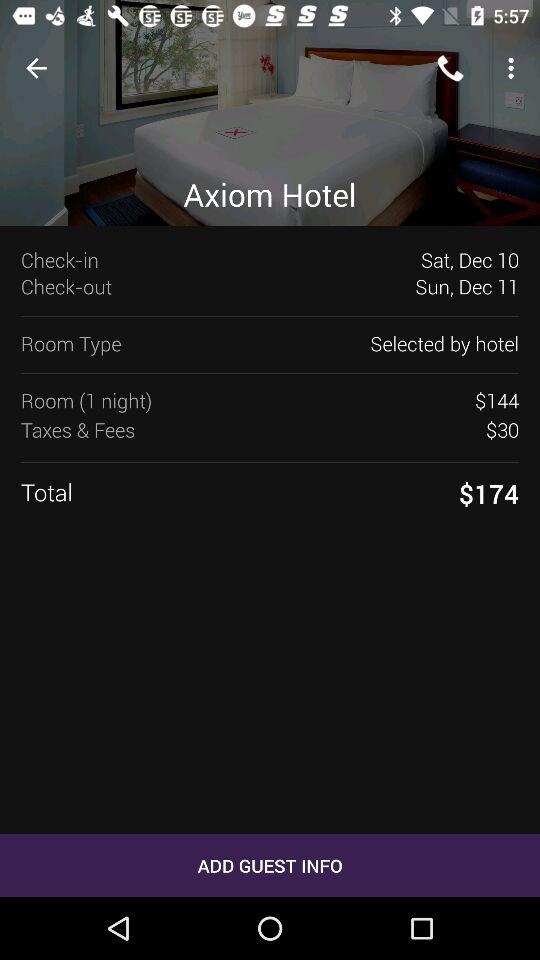What are the taxes and fees for staying in the room for one night? The taxes and fees for staying in the room for one night are $30. 